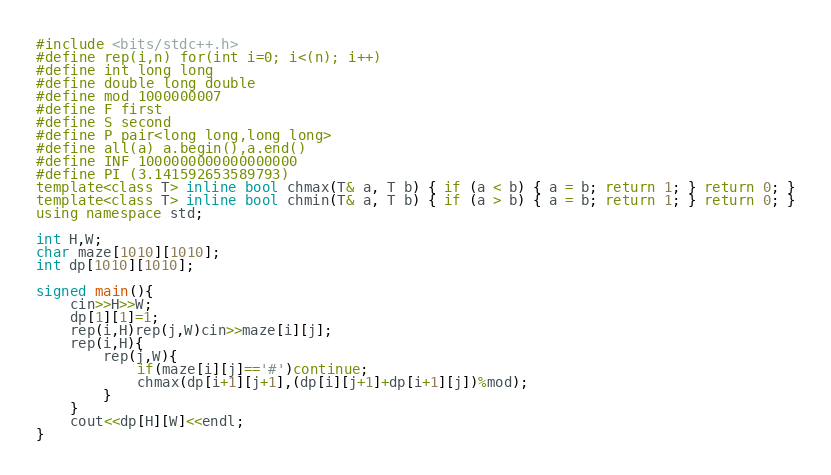Convert code to text. <code><loc_0><loc_0><loc_500><loc_500><_C++_>#include <bits/stdc++.h>
#define rep(i,n) for(int i=0; i<(n); i++)
#define int long long
#define double long double
#define mod 1000000007
#define F first
#define S second
#define P pair<long long,long long>
#define all(a) a.begin(),a.end()
#define INF 1000000000000000000
#define PI (3.141592653589793)
template<class T> inline bool chmax(T& a, T b) { if (a < b) { a = b; return 1; } return 0; }
template<class T> inline bool chmin(T& a, T b) { if (a > b) { a = b; return 1; } return 0; }
using namespace std;

int H,W;
char maze[1010][1010];
int dp[1010][1010];

signed main(){
    cin>>H>>W;
    dp[1][1]=1;
    rep(i,H)rep(j,W)cin>>maze[i][j];
    rep(i,H){
        rep(j,W){
            if(maze[i][j]=='#')continue;
            chmax(dp[i+1][j+1],(dp[i][j+1]+dp[i+1][j])%mod);
        }
    }
    cout<<dp[H][W]<<endl;
}</code> 